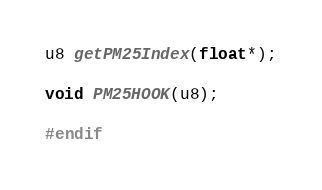<code> <loc_0><loc_0><loc_500><loc_500><_C_>
u8 getPM25Index(float*);

void PM25HOOK(u8);

#endif

</code> 